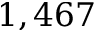Convert formula to latex. <formula><loc_0><loc_0><loc_500><loc_500>1 , 4 6 7</formula> 